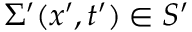Convert formula to latex. <formula><loc_0><loc_0><loc_500><loc_500>\Sigma ^ { \prime } ( x ^ { \prime } , t ^ { \prime } ) \in S ^ { \prime }</formula> 